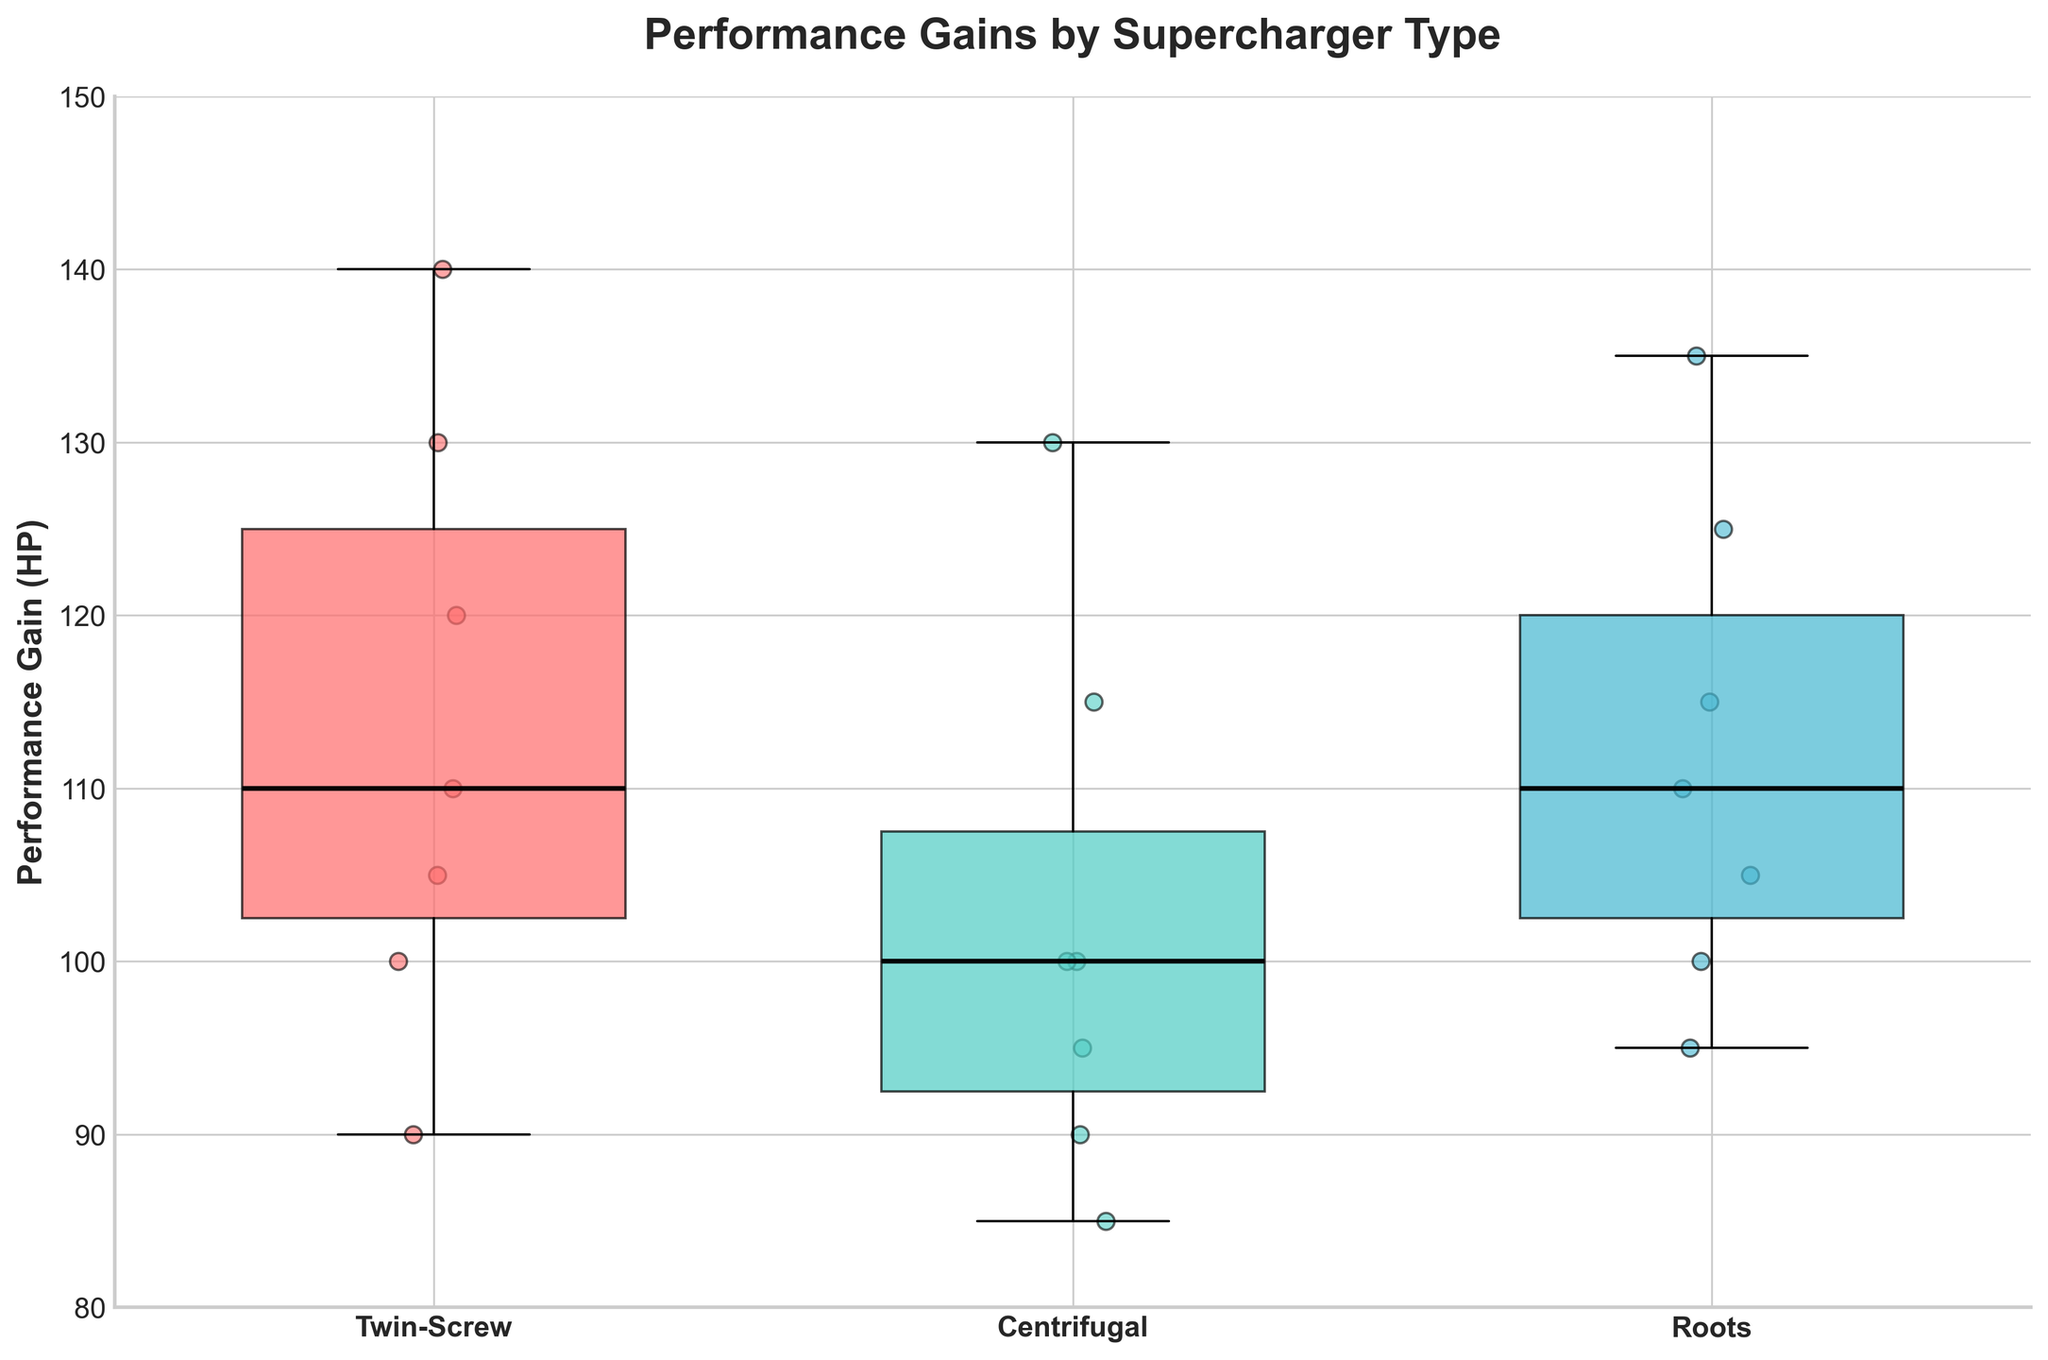What's the title of the plot? The title of the plot is usually displayed at the top center of the figure. In this case, it is "Performance Gains by Supercharger Type."
Answer: Performance Gains by Supercharger Type Which supercharger type has the highest median performance gain? To find the median, observe the line inside the box for each supercharger type. The median for the Twin-Screw supercharger is higher compared to Centrifugal and Roots types.
Answer: Twin-Screw How many car models were tested with the Centrifugal supercharger? To find this, look at the number of data points (small circles) scattered around the Centrifugal supercharger's box. There are 7 data points for Centrifugal.
Answer: 7 What is the range of performance gains for the Roots supercharger? The range is the difference between the maximum and minimum values. For the Roots supercharger, the maximum is around 135 HP, and the minimum is around 95 HP. So, the range is 135 - 95.
Answer: 40 HP Which supercharger type has the smallest interquartile range (IQR)? The IQR is the width of the box in the box plot. Observing the boxes, the Centrifugal supercharger has the smallest width, indicating the smallest IQR.
Answer: Centrifugal What is the median performance gain for the Toyota Supra with a Twin-Screw supercharger? The median performance gain for a specific supercharger and car model is shown by the line within the box. For Twin-Screw superchargers, the Toyota Supra's median is extracted from the corresponding box; it's around 110 HP.
Answer: 110 HP Compare the second and third quartile of the performance gain for the Twin-Screw and Roots superchargers. Which one shows a larger range? The second and third quartiles are represented by the upper and lower parts of the box. For the Twin-Screw, it ranges from about 105 HP to 135 HP (a range of 30 HP), while for the Roots, it ranges from about 100 HP to 125 HP (a range of 25 HP). Twin-Screw has a larger range.
Answer: Twin-Screw Across all car models, which supercharger type shows the most considerable overall performance improvement? Considering the general elevation of data points and the positions of the boxes, the Twin-Screw supercharger has the highest median values and generally higher performance gains.
Answer: Twin-Screw What's the average performance gain of the Twin-Screw supercharger for all car models? To find the average, sum all performance gains for the Twin-Screw supercharger (120 + 130 + 140 + 90 + 100 + 105 + 110) and divide by the number of data points (7). The sum is 795 HP, and the average is 795/7.
Answer: 113.57 HP Which supercharger type has the lowest lower whisker and what car model does it correspond to? The lower whisker represents the minimum value excluding outliers. The Centrifugal supercharger has the lowest lower whisker, which for the BMW M3 corresponds to about 85 HP.
Answer: Centrifugal, BMW M3 